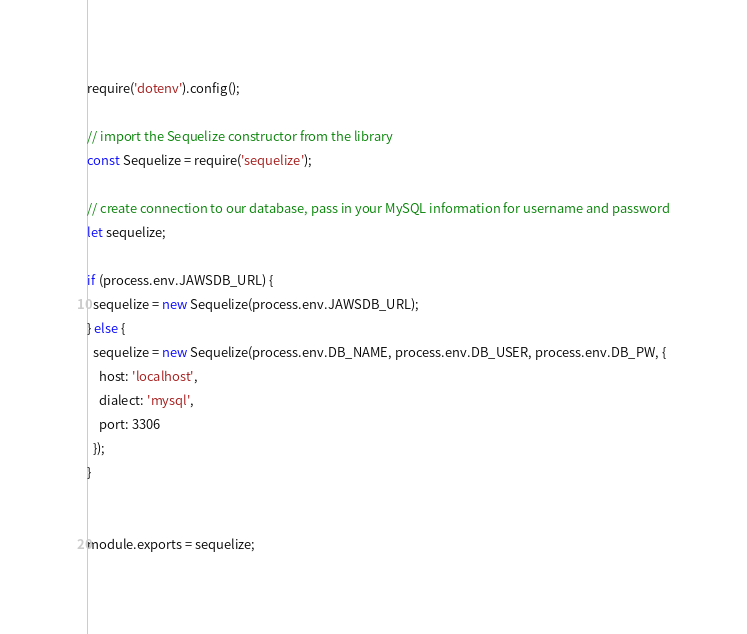<code> <loc_0><loc_0><loc_500><loc_500><_JavaScript_>require('dotenv').config();

// import the Sequelize constructor from the library
const Sequelize = require('sequelize');

// create connection to our database, pass in your MySQL information for username and password
let sequelize;

if (process.env.JAWSDB_URL) {
  sequelize = new Sequelize(process.env.JAWSDB_URL);
} else {
  sequelize = new Sequelize(process.env.DB_NAME, process.env.DB_USER, process.env.DB_PW, {
    host: 'localhost',
    dialect: 'mysql',
    port: 3306
  });
}


module.exports = sequelize;</code> 